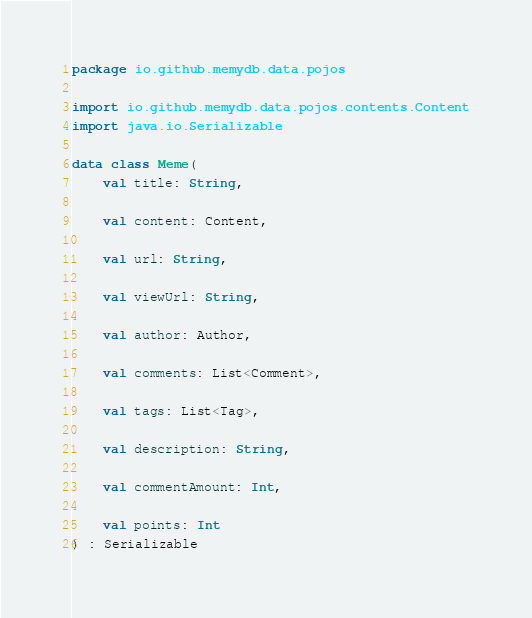Convert code to text. <code><loc_0><loc_0><loc_500><loc_500><_Kotlin_>package io.github.memydb.data.pojos

import io.github.memydb.data.pojos.contents.Content
import java.io.Serializable

data class Meme(
    val title: String,

    val content: Content,

    val url: String,

    val viewUrl: String,

    val author: Author,

    val comments: List<Comment>,

    val tags: List<Tag>,

    val description: String,

    val commentAmount: Int,

    val points: Int
) : Serializable
</code> 